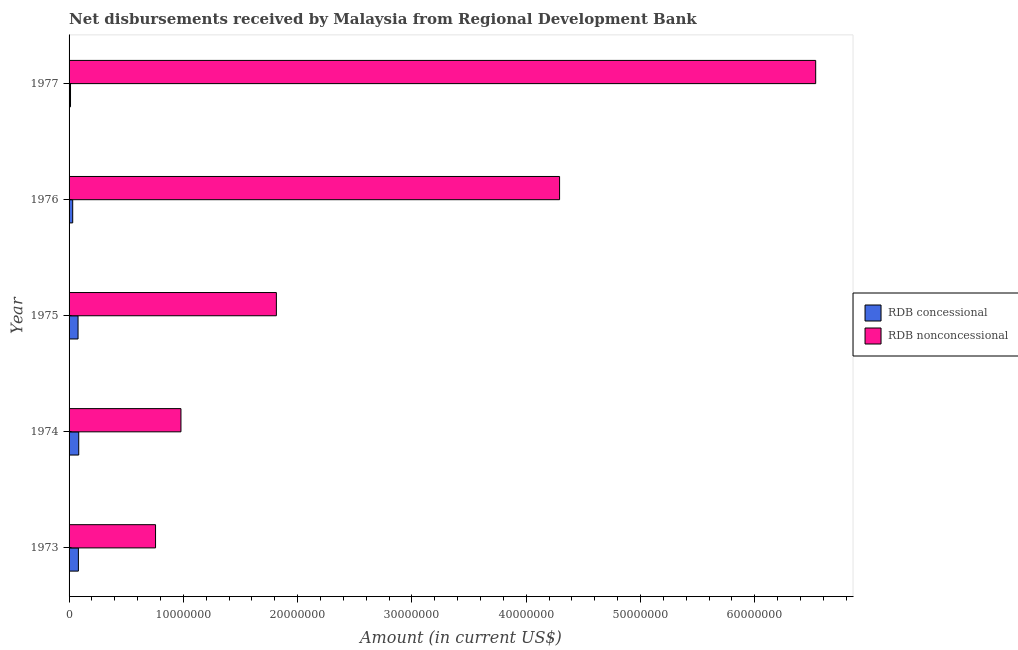Are the number of bars per tick equal to the number of legend labels?
Your response must be concise. Yes. Are the number of bars on each tick of the Y-axis equal?
Make the answer very short. Yes. In how many cases, is the number of bars for a given year not equal to the number of legend labels?
Ensure brevity in your answer.  0. What is the net non concessional disbursements from rdb in 1977?
Your answer should be very brief. 6.53e+07. Across all years, what is the maximum net concessional disbursements from rdb?
Offer a very short reply. 8.46e+05. Across all years, what is the minimum net non concessional disbursements from rdb?
Provide a succinct answer. 7.57e+06. In which year was the net non concessional disbursements from rdb maximum?
Offer a very short reply. 1977. What is the total net concessional disbursements from rdb in the graph?
Give a very brief answer. 2.89e+06. What is the difference between the net non concessional disbursements from rdb in 1973 and that in 1976?
Ensure brevity in your answer.  -3.54e+07. What is the difference between the net non concessional disbursements from rdb in 1975 and the net concessional disbursements from rdb in 1974?
Offer a very short reply. 1.73e+07. What is the average net concessional disbursements from rdb per year?
Ensure brevity in your answer.  5.78e+05. In the year 1975, what is the difference between the net non concessional disbursements from rdb and net concessional disbursements from rdb?
Your response must be concise. 1.74e+07. What is the ratio of the net non concessional disbursements from rdb in 1975 to that in 1977?
Your answer should be compact. 0.28. Is the net non concessional disbursements from rdb in 1975 less than that in 1977?
Provide a succinct answer. Yes. What is the difference between the highest and the second highest net non concessional disbursements from rdb?
Ensure brevity in your answer.  2.24e+07. What is the difference between the highest and the lowest net non concessional disbursements from rdb?
Offer a very short reply. 5.78e+07. Is the sum of the net concessional disbursements from rdb in 1974 and 1976 greater than the maximum net non concessional disbursements from rdb across all years?
Give a very brief answer. No. What does the 2nd bar from the top in 1974 represents?
Your response must be concise. RDB concessional. What does the 1st bar from the bottom in 1974 represents?
Ensure brevity in your answer.  RDB concessional. How many bars are there?
Provide a short and direct response. 10. Are all the bars in the graph horizontal?
Your response must be concise. Yes. What is the difference between two consecutive major ticks on the X-axis?
Make the answer very short. 1.00e+07. Does the graph contain any zero values?
Provide a succinct answer. No. How many legend labels are there?
Provide a short and direct response. 2. How are the legend labels stacked?
Your response must be concise. Vertical. What is the title of the graph?
Keep it short and to the point. Net disbursements received by Malaysia from Regional Development Bank. What is the label or title of the X-axis?
Provide a succinct answer. Amount (in current US$). What is the label or title of the Y-axis?
Offer a very short reply. Year. What is the Amount (in current US$) in RDB concessional in 1973?
Your response must be concise. 8.15e+05. What is the Amount (in current US$) in RDB nonconcessional in 1973?
Provide a succinct answer. 7.57e+06. What is the Amount (in current US$) of RDB concessional in 1974?
Provide a succinct answer. 8.46e+05. What is the Amount (in current US$) of RDB nonconcessional in 1974?
Your answer should be compact. 9.79e+06. What is the Amount (in current US$) in RDB concessional in 1975?
Make the answer very short. 7.85e+05. What is the Amount (in current US$) of RDB nonconcessional in 1975?
Offer a terse response. 1.81e+07. What is the Amount (in current US$) in RDB concessional in 1976?
Offer a terse response. 3.18e+05. What is the Amount (in current US$) of RDB nonconcessional in 1976?
Offer a very short reply. 4.29e+07. What is the Amount (in current US$) in RDB concessional in 1977?
Give a very brief answer. 1.26e+05. What is the Amount (in current US$) of RDB nonconcessional in 1977?
Give a very brief answer. 6.53e+07. Across all years, what is the maximum Amount (in current US$) of RDB concessional?
Offer a terse response. 8.46e+05. Across all years, what is the maximum Amount (in current US$) in RDB nonconcessional?
Ensure brevity in your answer.  6.53e+07. Across all years, what is the minimum Amount (in current US$) of RDB concessional?
Provide a succinct answer. 1.26e+05. Across all years, what is the minimum Amount (in current US$) in RDB nonconcessional?
Your response must be concise. 7.57e+06. What is the total Amount (in current US$) of RDB concessional in the graph?
Keep it short and to the point. 2.89e+06. What is the total Amount (in current US$) in RDB nonconcessional in the graph?
Give a very brief answer. 1.44e+08. What is the difference between the Amount (in current US$) of RDB concessional in 1973 and that in 1974?
Your answer should be compact. -3.10e+04. What is the difference between the Amount (in current US$) of RDB nonconcessional in 1973 and that in 1974?
Offer a terse response. -2.22e+06. What is the difference between the Amount (in current US$) in RDB concessional in 1973 and that in 1975?
Give a very brief answer. 3.00e+04. What is the difference between the Amount (in current US$) of RDB nonconcessional in 1973 and that in 1975?
Your response must be concise. -1.06e+07. What is the difference between the Amount (in current US$) in RDB concessional in 1973 and that in 1976?
Offer a very short reply. 4.97e+05. What is the difference between the Amount (in current US$) in RDB nonconcessional in 1973 and that in 1976?
Ensure brevity in your answer.  -3.54e+07. What is the difference between the Amount (in current US$) in RDB concessional in 1973 and that in 1977?
Provide a succinct answer. 6.89e+05. What is the difference between the Amount (in current US$) of RDB nonconcessional in 1973 and that in 1977?
Make the answer very short. -5.78e+07. What is the difference between the Amount (in current US$) of RDB concessional in 1974 and that in 1975?
Offer a terse response. 6.10e+04. What is the difference between the Amount (in current US$) in RDB nonconcessional in 1974 and that in 1975?
Your answer should be compact. -8.35e+06. What is the difference between the Amount (in current US$) in RDB concessional in 1974 and that in 1976?
Your answer should be very brief. 5.28e+05. What is the difference between the Amount (in current US$) in RDB nonconcessional in 1974 and that in 1976?
Make the answer very short. -3.31e+07. What is the difference between the Amount (in current US$) of RDB concessional in 1974 and that in 1977?
Keep it short and to the point. 7.20e+05. What is the difference between the Amount (in current US$) in RDB nonconcessional in 1974 and that in 1977?
Give a very brief answer. -5.55e+07. What is the difference between the Amount (in current US$) in RDB concessional in 1975 and that in 1976?
Ensure brevity in your answer.  4.67e+05. What is the difference between the Amount (in current US$) in RDB nonconcessional in 1975 and that in 1976?
Provide a short and direct response. -2.48e+07. What is the difference between the Amount (in current US$) of RDB concessional in 1975 and that in 1977?
Offer a terse response. 6.59e+05. What is the difference between the Amount (in current US$) in RDB nonconcessional in 1975 and that in 1977?
Give a very brief answer. -4.72e+07. What is the difference between the Amount (in current US$) in RDB concessional in 1976 and that in 1977?
Provide a short and direct response. 1.92e+05. What is the difference between the Amount (in current US$) in RDB nonconcessional in 1976 and that in 1977?
Ensure brevity in your answer.  -2.24e+07. What is the difference between the Amount (in current US$) in RDB concessional in 1973 and the Amount (in current US$) in RDB nonconcessional in 1974?
Offer a very short reply. -8.97e+06. What is the difference between the Amount (in current US$) in RDB concessional in 1973 and the Amount (in current US$) in RDB nonconcessional in 1975?
Your answer should be very brief. -1.73e+07. What is the difference between the Amount (in current US$) in RDB concessional in 1973 and the Amount (in current US$) in RDB nonconcessional in 1976?
Offer a terse response. -4.21e+07. What is the difference between the Amount (in current US$) in RDB concessional in 1973 and the Amount (in current US$) in RDB nonconcessional in 1977?
Ensure brevity in your answer.  -6.45e+07. What is the difference between the Amount (in current US$) of RDB concessional in 1974 and the Amount (in current US$) of RDB nonconcessional in 1975?
Your answer should be compact. -1.73e+07. What is the difference between the Amount (in current US$) of RDB concessional in 1974 and the Amount (in current US$) of RDB nonconcessional in 1976?
Offer a very short reply. -4.21e+07. What is the difference between the Amount (in current US$) in RDB concessional in 1974 and the Amount (in current US$) in RDB nonconcessional in 1977?
Make the answer very short. -6.45e+07. What is the difference between the Amount (in current US$) of RDB concessional in 1975 and the Amount (in current US$) of RDB nonconcessional in 1976?
Offer a terse response. -4.21e+07. What is the difference between the Amount (in current US$) in RDB concessional in 1975 and the Amount (in current US$) in RDB nonconcessional in 1977?
Offer a terse response. -6.45e+07. What is the difference between the Amount (in current US$) of RDB concessional in 1976 and the Amount (in current US$) of RDB nonconcessional in 1977?
Provide a short and direct response. -6.50e+07. What is the average Amount (in current US$) in RDB concessional per year?
Provide a short and direct response. 5.78e+05. What is the average Amount (in current US$) in RDB nonconcessional per year?
Your answer should be compact. 2.87e+07. In the year 1973, what is the difference between the Amount (in current US$) in RDB concessional and Amount (in current US$) in RDB nonconcessional?
Offer a very short reply. -6.75e+06. In the year 1974, what is the difference between the Amount (in current US$) of RDB concessional and Amount (in current US$) of RDB nonconcessional?
Provide a short and direct response. -8.94e+06. In the year 1975, what is the difference between the Amount (in current US$) of RDB concessional and Amount (in current US$) of RDB nonconcessional?
Ensure brevity in your answer.  -1.74e+07. In the year 1976, what is the difference between the Amount (in current US$) in RDB concessional and Amount (in current US$) in RDB nonconcessional?
Offer a terse response. -4.26e+07. In the year 1977, what is the difference between the Amount (in current US$) of RDB concessional and Amount (in current US$) of RDB nonconcessional?
Give a very brief answer. -6.52e+07. What is the ratio of the Amount (in current US$) in RDB concessional in 1973 to that in 1974?
Your answer should be compact. 0.96. What is the ratio of the Amount (in current US$) of RDB nonconcessional in 1973 to that in 1974?
Keep it short and to the point. 0.77. What is the ratio of the Amount (in current US$) of RDB concessional in 1973 to that in 1975?
Give a very brief answer. 1.04. What is the ratio of the Amount (in current US$) of RDB nonconcessional in 1973 to that in 1975?
Provide a short and direct response. 0.42. What is the ratio of the Amount (in current US$) in RDB concessional in 1973 to that in 1976?
Your response must be concise. 2.56. What is the ratio of the Amount (in current US$) in RDB nonconcessional in 1973 to that in 1976?
Keep it short and to the point. 0.18. What is the ratio of the Amount (in current US$) in RDB concessional in 1973 to that in 1977?
Your response must be concise. 6.47. What is the ratio of the Amount (in current US$) in RDB nonconcessional in 1973 to that in 1977?
Provide a short and direct response. 0.12. What is the ratio of the Amount (in current US$) in RDB concessional in 1974 to that in 1975?
Your answer should be compact. 1.08. What is the ratio of the Amount (in current US$) in RDB nonconcessional in 1974 to that in 1975?
Provide a succinct answer. 0.54. What is the ratio of the Amount (in current US$) of RDB concessional in 1974 to that in 1976?
Your answer should be compact. 2.66. What is the ratio of the Amount (in current US$) in RDB nonconcessional in 1974 to that in 1976?
Provide a succinct answer. 0.23. What is the ratio of the Amount (in current US$) of RDB concessional in 1974 to that in 1977?
Give a very brief answer. 6.71. What is the ratio of the Amount (in current US$) in RDB nonconcessional in 1974 to that in 1977?
Provide a short and direct response. 0.15. What is the ratio of the Amount (in current US$) of RDB concessional in 1975 to that in 1976?
Ensure brevity in your answer.  2.47. What is the ratio of the Amount (in current US$) of RDB nonconcessional in 1975 to that in 1976?
Ensure brevity in your answer.  0.42. What is the ratio of the Amount (in current US$) of RDB concessional in 1975 to that in 1977?
Provide a short and direct response. 6.23. What is the ratio of the Amount (in current US$) in RDB nonconcessional in 1975 to that in 1977?
Offer a very short reply. 0.28. What is the ratio of the Amount (in current US$) in RDB concessional in 1976 to that in 1977?
Give a very brief answer. 2.52. What is the ratio of the Amount (in current US$) in RDB nonconcessional in 1976 to that in 1977?
Provide a short and direct response. 0.66. What is the difference between the highest and the second highest Amount (in current US$) of RDB concessional?
Ensure brevity in your answer.  3.10e+04. What is the difference between the highest and the second highest Amount (in current US$) of RDB nonconcessional?
Your answer should be compact. 2.24e+07. What is the difference between the highest and the lowest Amount (in current US$) of RDB concessional?
Make the answer very short. 7.20e+05. What is the difference between the highest and the lowest Amount (in current US$) of RDB nonconcessional?
Offer a terse response. 5.78e+07. 